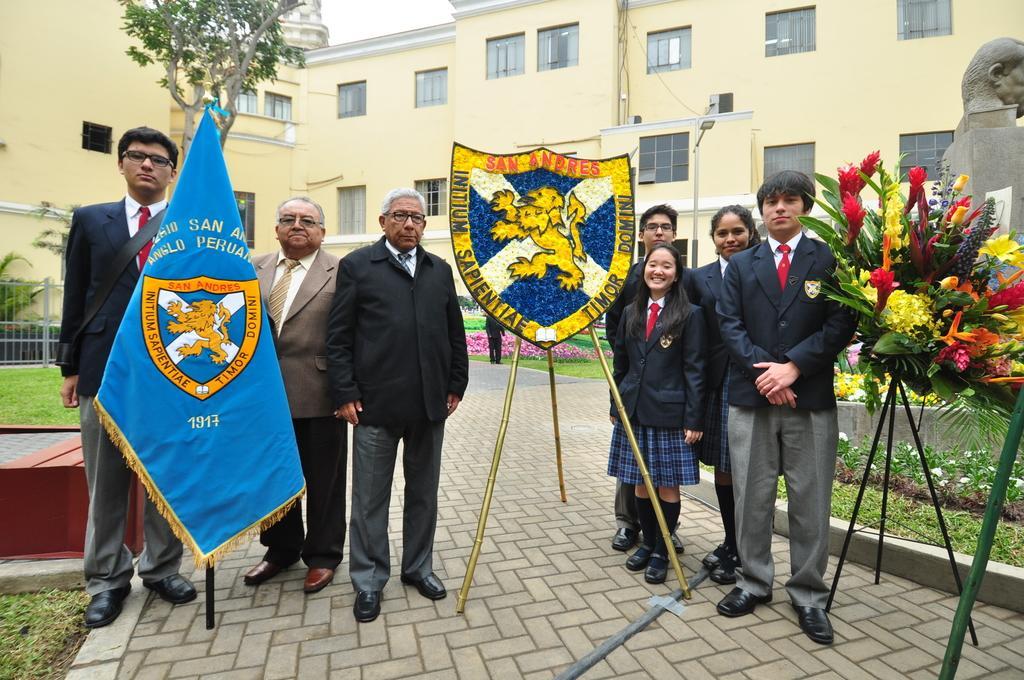In one or two sentences, can you explain what this image depicts? There are many people standing. In the back there is a flag on a pole. Also there is an emblem on a tripod stand. There is a flower bouquet on a stand. In the back there is a building with windows. On the right side there is a statue on a platform. On the ground there are plants and grass. In the back there is a railing. In the background there is tree. 